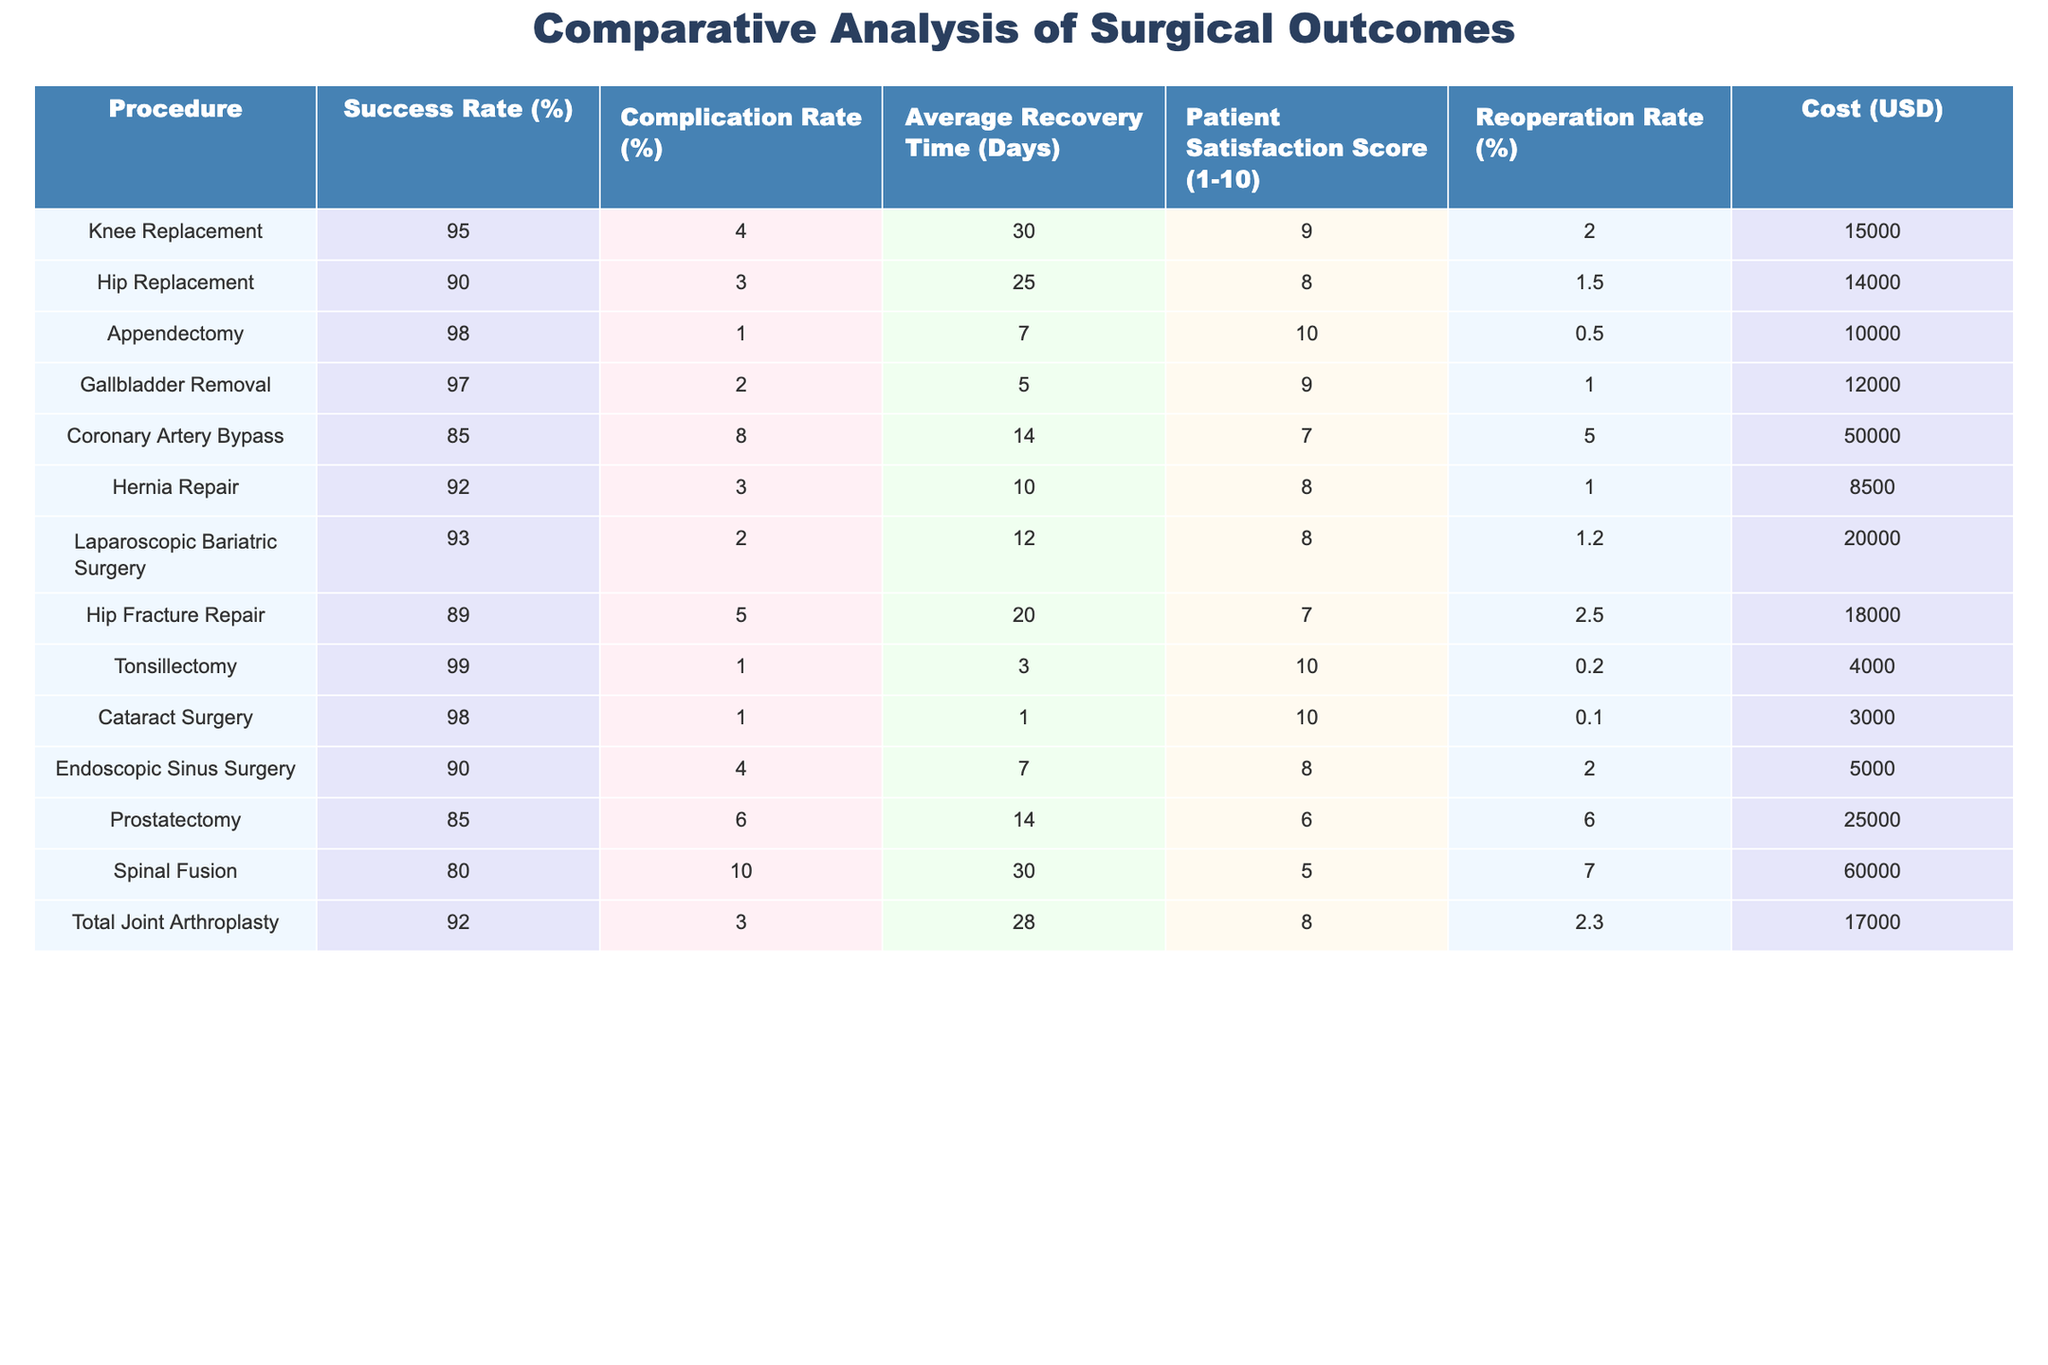What is the success rate of Hip Replacement surgery? Referring to the table, the success rate for Hip Replacement is listed as 90%.
Answer: 90% What is the cost of Tonsillectomy? The table specifies that the cost for a Tonsillectomy procedure is $4,000.
Answer: $4,000 Which procedure has the highest patient satisfaction score? By reviewing the patient satisfaction scores in the table, the Tonsillectomy and Cataract Surgery both have the highest score of 10.
Answer: 10 What is the average recovery time for Coronary Artery Bypass and Spinal Fusion combined? The average recovery time for Coronary Artery Bypass is 14 days and for Spinal Fusion it is 30 days. Adding these gives 14 + 30 = 44 days. Dividing by 2 gives an average of 22 days.
Answer: 22 days Is the reoperation rate for Gallbladder Removal lower than that for Hernia Repair? The reoperation rate for Gallbladder Removal is 1% while for Hernia Repair it is 1%. Since both rates are equal, the answer is no.
Answer: No What is the difference in success rates between Knee Replacement and Hip Fracture Repair? The success rate for Knee Replacement is 95% and for Hip Fracture Repair it is 89%. The difference is 95 - 89 = 6%.
Answer: 6% What is the total cost of performing a Hip Replacement and a Laparoscopic Bariatric Surgery? The cost for Hip Replacement is $14,000 and for Laparoscopic Bariatric Surgery it is $20,000. Adding these gives a total cost of 14,000 + 20,000 = $34,000.
Answer: $34,000 Are there any procedures with a complication rate lower than 3%? Looking at the complication rates in the table, both Appendectomy and Tonsillectomy have complication rates of 1%, which are lower than 3%. Thus, the answer is yes.
Answer: Yes What is the average patient satisfaction score for procedures with a success rate of 90% or higher? The procedures with a success rate of 90% or higher are Knee Replacement (9), Appendectomy (10), Gallbladder Removal (9), Hernia Repair (8), Laparoscopic Bariatric Surgery (8), Tonsillectomy (10), and Cataract Surgery (10). Summing these scores gives 9 + 10 + 9 + 8 + 8 + 10 + 10 = 74. There are 7 values, so the average is 74 / 7 ≈ 10.57.
Answer: 10.57 Which procedure has the highest complication rate and what is it? Upon checking the table, the procedure with the highest complication rate is Spinal Fusion, which has a complication rate of 10%.
Answer: 10% 